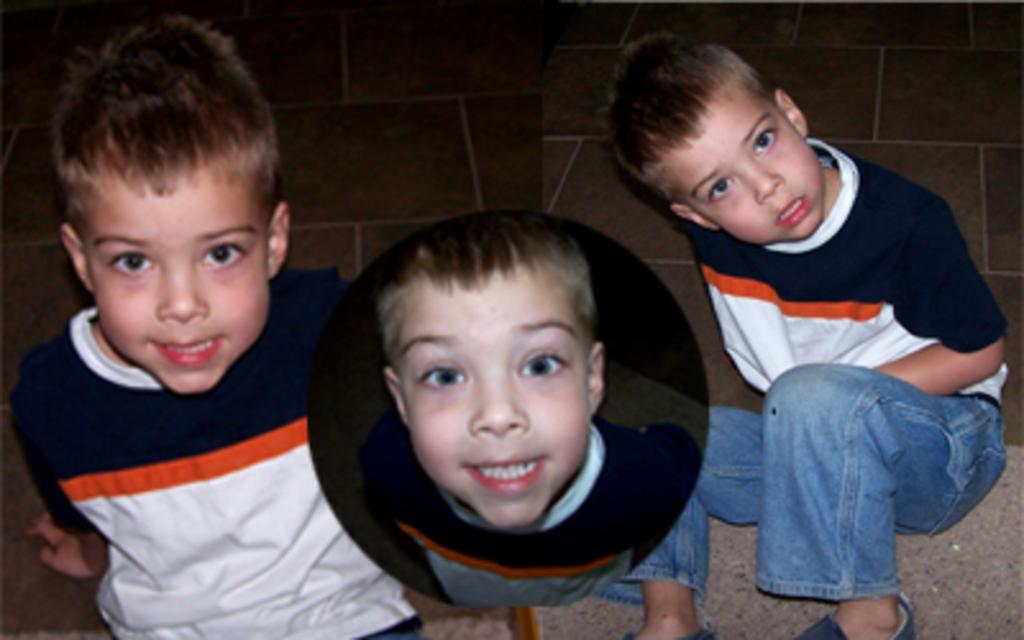What is the main subject of the image? The main subject of the image is three college photographs. What do the photographs depict? The photographs depict a small boy. What is the boy wearing in the photographs? The boy is wearing a white and blue t-shirt. What is the boy's position in the photographs? The boy is sitting on the ground. What is the boy's expression in the photographs? The boy is smiling. What is the boy doing in the photographs? The boy is posing for the camera. What type of mitten is the boy holding in the image? There is no mitten present in the image; the boy is wearing a white and blue t-shirt and sitting on the ground. 